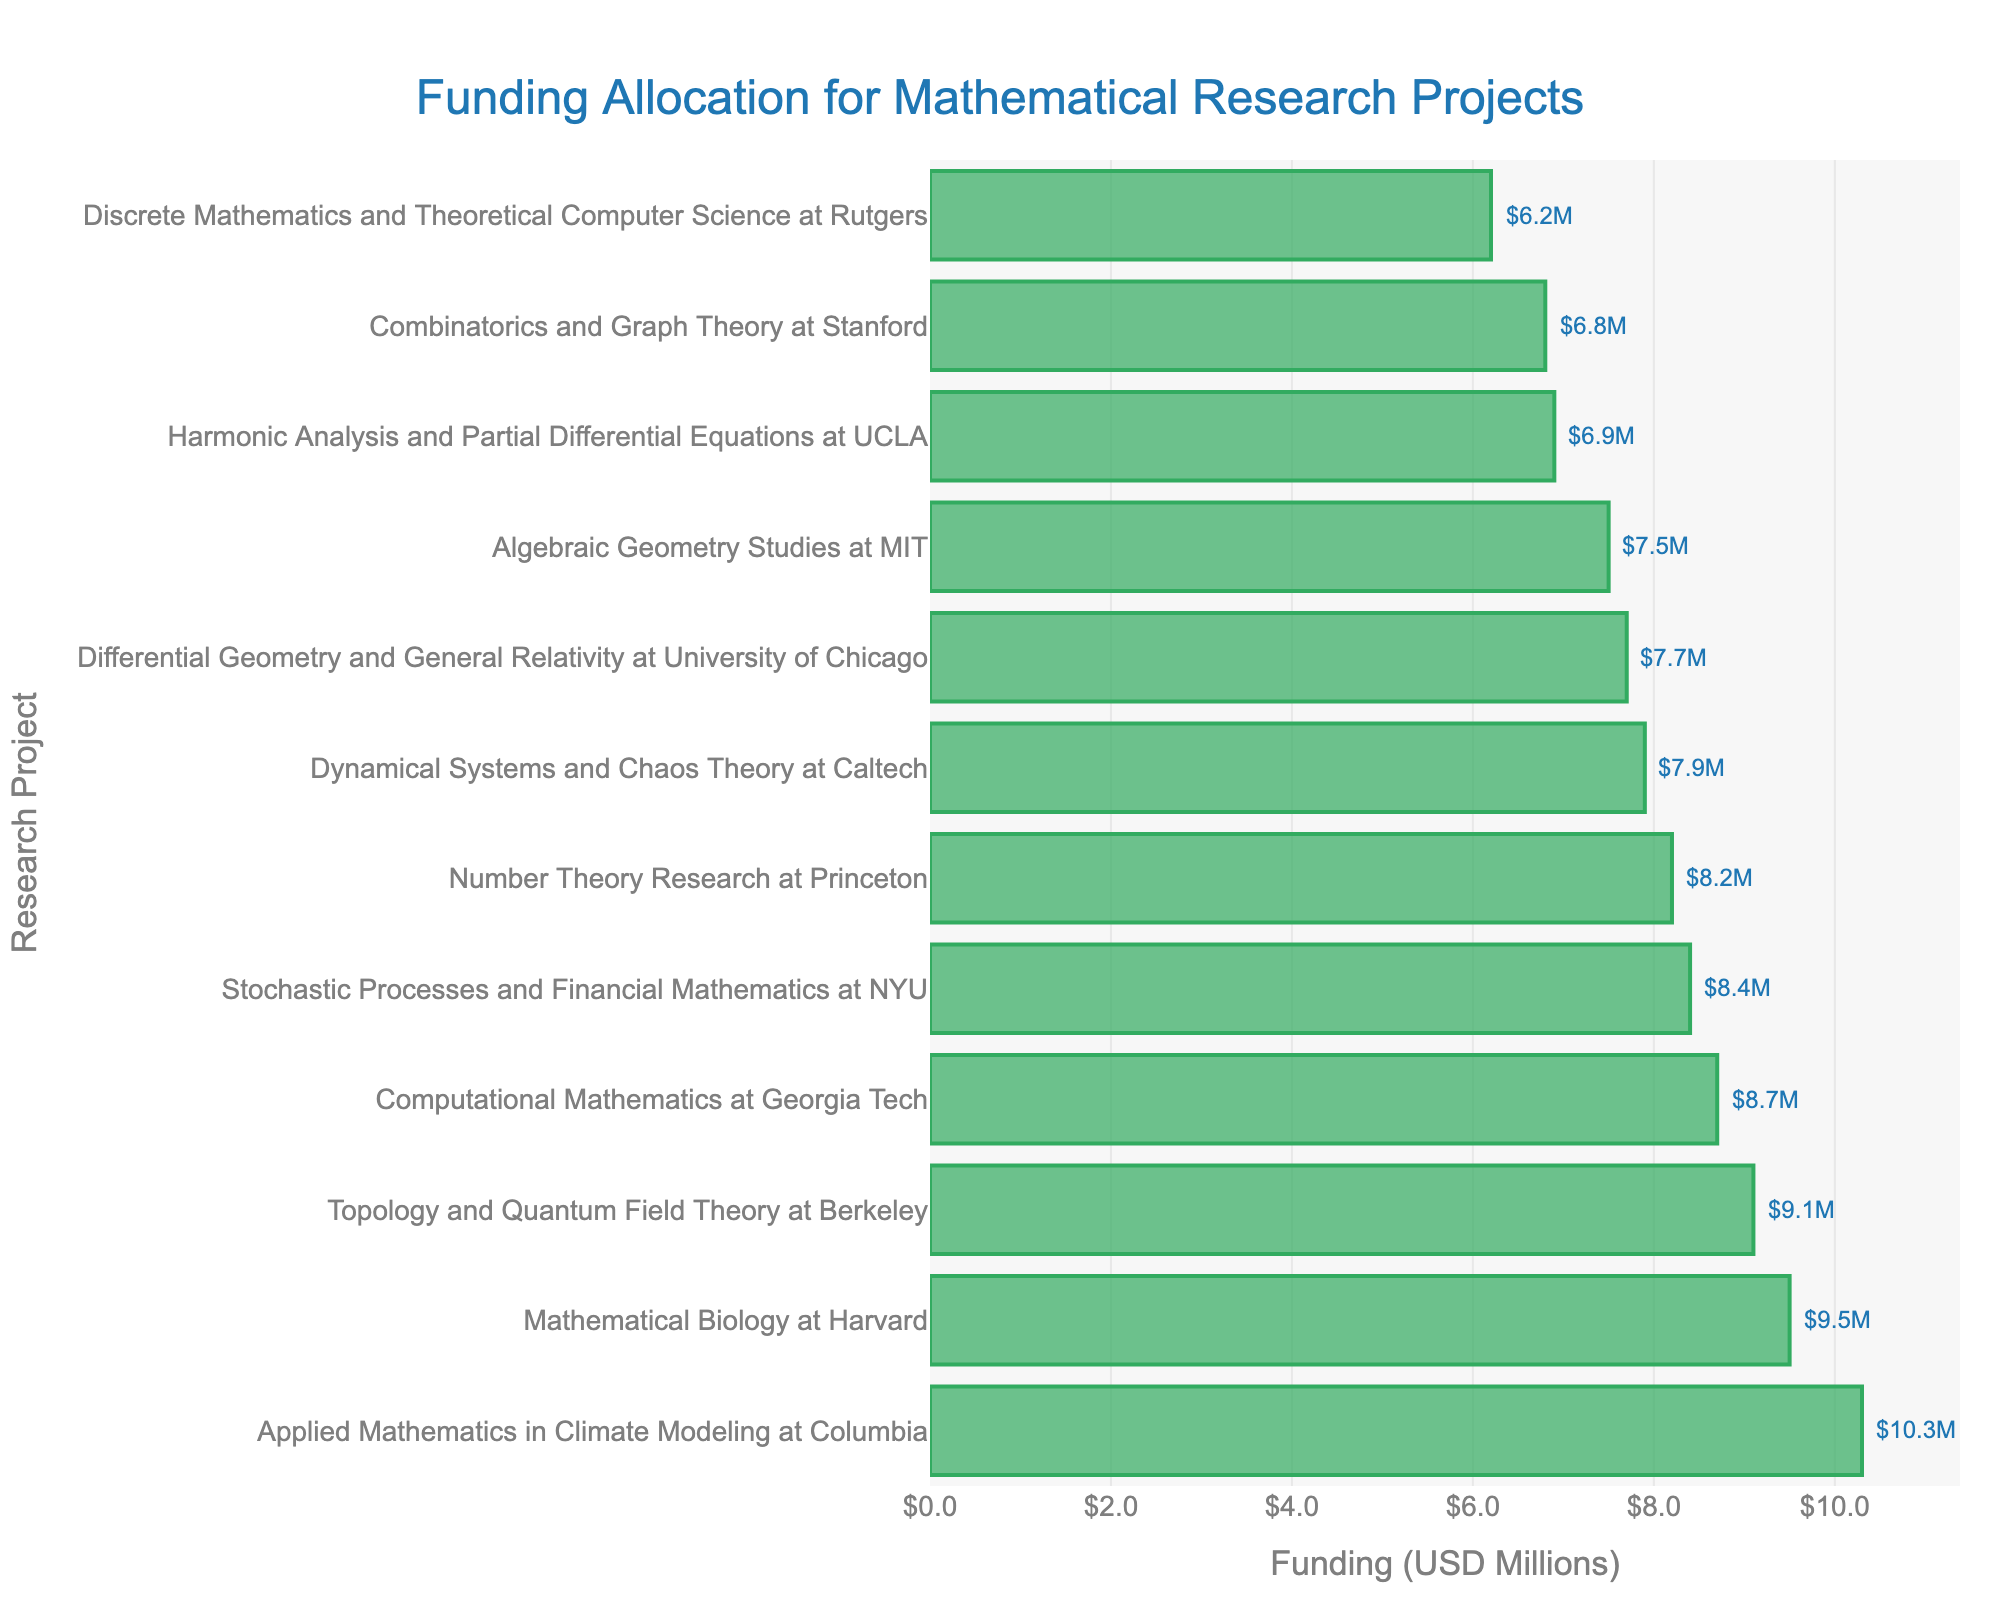Which project received the highest funding? The length of the bar representing "Applied Mathematics in Climate Modeling at Columbia" is the longest, and the annotated value is $10.3M.
Answer: Applied Mathematics in Climate Modeling at Columbia Compare the funding received for the "Mathematical Biology at Harvard" and the "Topology and Quantum Field Theory at Berkeley". Which one received more? By comparing the bar lengths and annotated values, "Mathematical Biology at Harvard" received $9.5M while "Topology and Quantum Field Theory at Berkeley" received $9.1M.
Answer: Mathematical Biology at Harvard What is the difference in funding between the "Algebraic Geometry Studies at MIT" and the "Discrete Mathematics and Theoretical Computer Science at Rutgers"? The funding for "Algebraic Geometry Studies at MIT" is $7.5M and for "Discrete Mathematics and Theoretical Computer Science at Rutgers" is $6.2M. The difference is $7.5M - $6.2M.
Answer: $1.3M Is the funding for "Stochastic Processes and Financial Mathematics at NYU" greater than that for "Dynamical Systems and Chaos Theory at Caltech"? The funding for "Stochastic Processes and Financial Mathematics at NYU" is $8.4M, and for "Dynamical Systems and Chaos Theory at Caltech" is $7.9M. Since $8.4M > $7.9M, the answer is yes.
Answer: Yes How many projects received funding greater than $8M? Count the number of bars with annotated values greater than $8M. These include Princeton, Berkeley, Georgia Tech, Harvard, and NYU projects. There are 5 such projects.
Answer: 5 Find the average funding for the projects at Harvard and Princeton. The funding for "Mathematical Biology at Harvard" is $9.5M, and for "Number Theory Research at Princeton" is $8.2M. The average is calculated as ($9.5M + $8.2M) / 2.
Answer: $8.85M Which project falls exactly in the middle in terms of funding amount? After sorting the projects by funding value, the one in the middle (6th position, given there are 12 projects) is "Dynamical Systems and Chaos Theory at Caltech" with funding of $7.9M.
Answer: Dynamical Systems and Chaos Theory at Caltech What is the total funding for the projects by Stanford, MIT, and NYU? Summing the funding amounts: Stanford ($6.8M) + MIT ($7.5M) + NYU ($8.4M). The total is $6.8M + $7.5M + $8.4M.
Answer: $22.7M Does any project have exactly $9M in funding? By inspecting the annotated values, none of the projects received exactly $9M.
Answer: No Order the universities by funding from highest to lowest. The annotated values in descending order are: Columbia ($10.3M), Harvard ($9.5M), Berkeley ($9.1M), Georgia Tech ($8.7M), NYU ($8.4M), Princeton ($8.2M), Caltech ($7.9M), University of Chicago ($7.7M), MIT ($7.5M), UCLA ($6.9M), Stanford ($6.8M), and Rutgers ($6.2M).
Answer: Columbia, Harvard, Berkeley, Georgia Tech, NYU, Princeton, Caltech, University of Chicago, MIT, UCLA, Stanford, Rutgers 